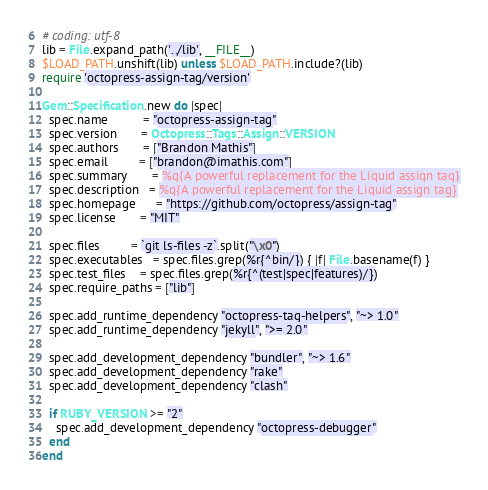<code> <loc_0><loc_0><loc_500><loc_500><_Ruby_># coding: utf-8
lib = File.expand_path('../lib', __FILE__)
$LOAD_PATH.unshift(lib) unless $LOAD_PATH.include?(lib)
require 'octopress-assign-tag/version'

Gem::Specification.new do |spec|
  spec.name          = "octopress-assign-tag"
  spec.version       = Octopress::Tags::Assign::VERSION
  spec.authors       = ["Brandon Mathis"]
  spec.email         = ["brandon@imathis.com"]
  spec.summary       = %q{A powerful replacement for the Liquid assign tag}
  spec.description   = %q{A powerful replacement for the Liquid assign tag}
  spec.homepage      = "https://github.com/octopress/assign-tag"
  spec.license       = "MIT"

  spec.files         = `git ls-files -z`.split("\x0")
  spec.executables   = spec.files.grep(%r{^bin/}) { |f| File.basename(f) }
  spec.test_files    = spec.files.grep(%r{^(test|spec|features)/})
  spec.require_paths = ["lib"]

  spec.add_runtime_dependency "octopress-tag-helpers", "~> 1.0"
  spec.add_runtime_dependency "jekyll", ">= 2.0"

  spec.add_development_dependency "bundler", "~> 1.6"
  spec.add_development_dependency "rake"
  spec.add_development_dependency "clash"

  if RUBY_VERSION >= "2"
    spec.add_development_dependency "octopress-debugger"
  end
end
</code> 